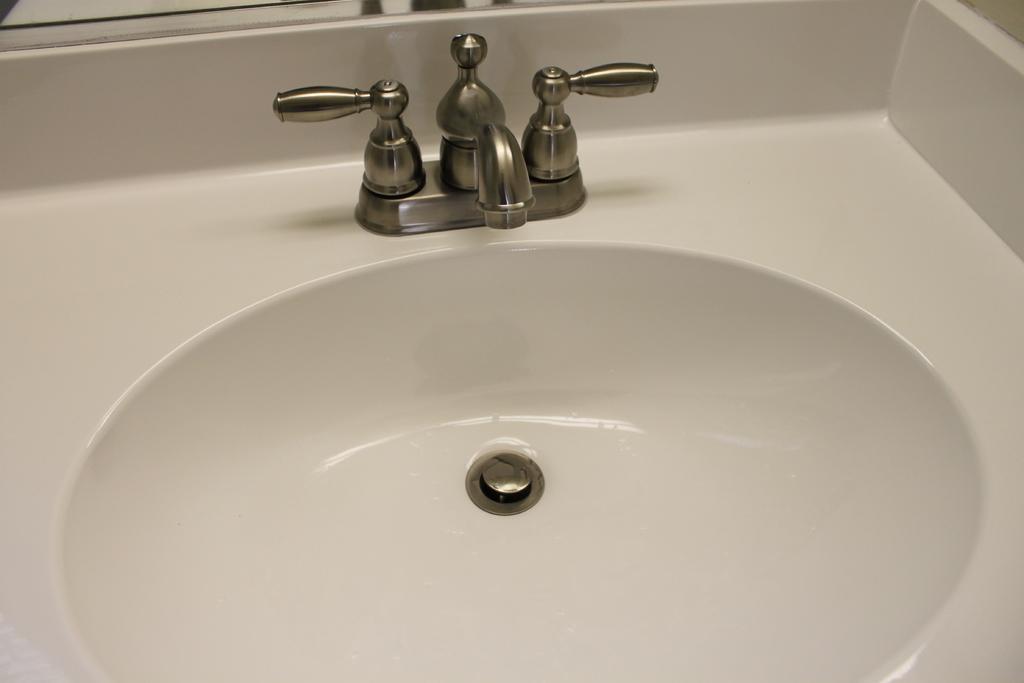In one or two sentences, can you explain what this image depicts? In the image in the center we can see one white color sink and one tap. 